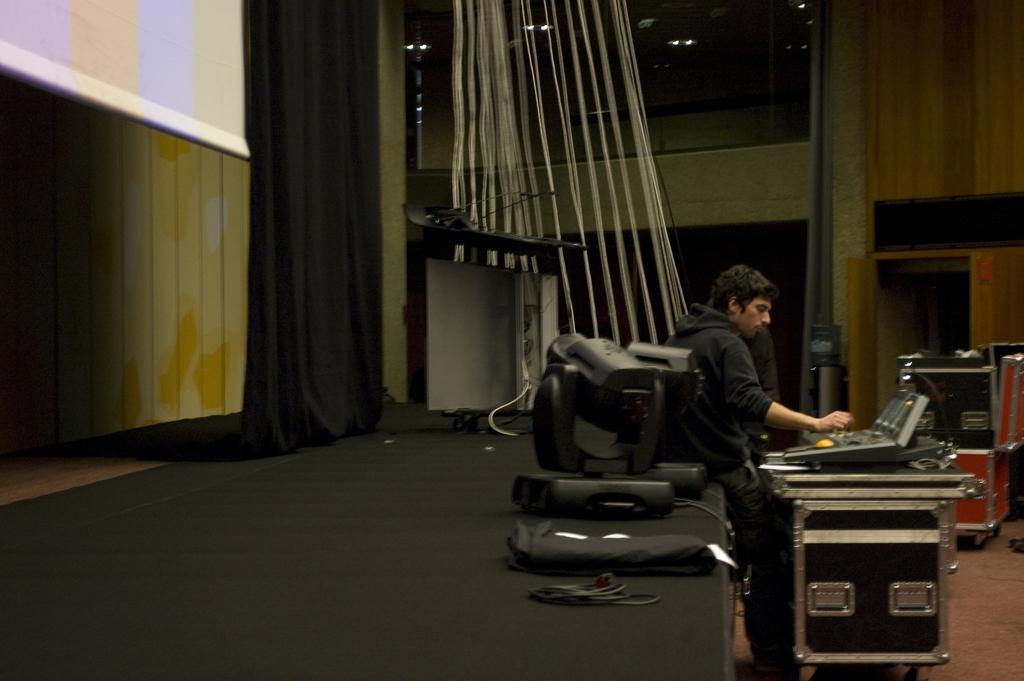In one or two sentences, can you explain what this image depicts? In this image there are objectś on the stage, there is a wall, there is a curtain, there is a person, there is a DJ controller on the surface, there is an object towards the right of the image. 